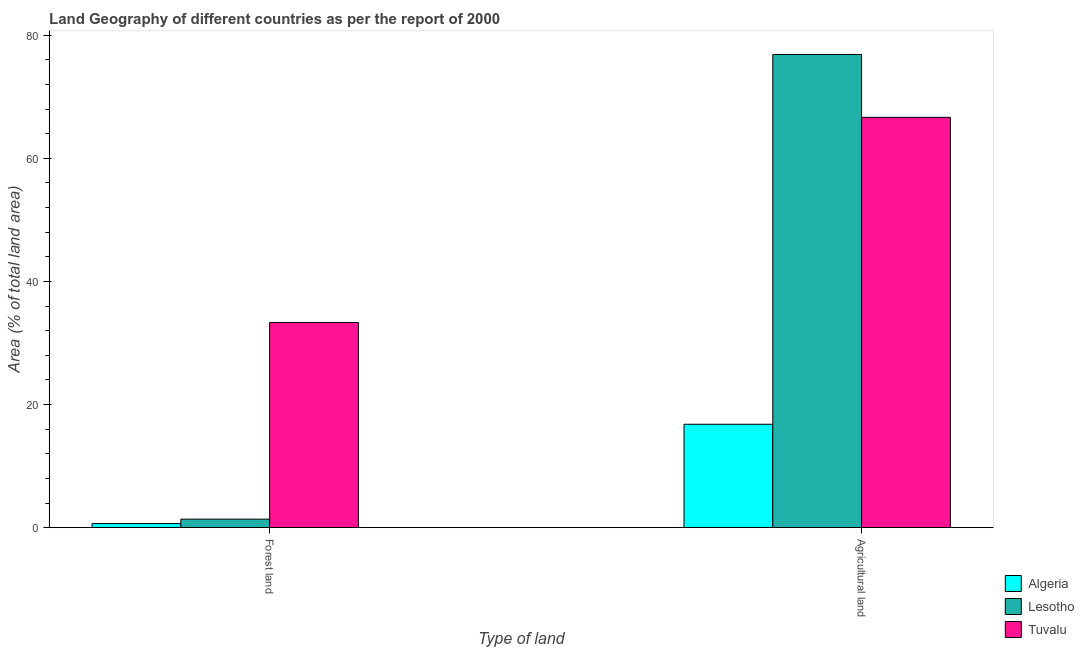How many groups of bars are there?
Make the answer very short. 2. Are the number of bars per tick equal to the number of legend labels?
Offer a terse response. Yes. How many bars are there on the 2nd tick from the right?
Give a very brief answer. 3. What is the label of the 1st group of bars from the left?
Give a very brief answer. Forest land. What is the percentage of land area under forests in Tuvalu?
Your response must be concise. 33.33. Across all countries, what is the maximum percentage of land area under forests?
Ensure brevity in your answer.  33.33. Across all countries, what is the minimum percentage of land area under forests?
Your answer should be compact. 0.66. In which country was the percentage of land area under forests maximum?
Give a very brief answer. Tuvalu. In which country was the percentage of land area under agriculture minimum?
Your response must be concise. Algeria. What is the total percentage of land area under agriculture in the graph?
Your answer should be compact. 160.35. What is the difference between the percentage of land area under agriculture in Tuvalu and that in Algeria?
Provide a succinct answer. 49.86. What is the difference between the percentage of land area under agriculture in Lesotho and the percentage of land area under forests in Algeria?
Give a very brief answer. 76.21. What is the average percentage of land area under forests per country?
Ensure brevity in your answer.  11.79. What is the difference between the percentage of land area under agriculture and percentage of land area under forests in Algeria?
Make the answer very short. 16.14. What is the ratio of the percentage of land area under forests in Tuvalu to that in Algeria?
Offer a very short reply. 50.28. What does the 2nd bar from the left in Agricultural land represents?
Your response must be concise. Lesotho. What does the 3rd bar from the right in Forest land represents?
Provide a short and direct response. Algeria. How many bars are there?
Provide a short and direct response. 6. Are all the bars in the graph horizontal?
Give a very brief answer. No. Does the graph contain grids?
Your answer should be compact. No. How many legend labels are there?
Make the answer very short. 3. What is the title of the graph?
Your answer should be very brief. Land Geography of different countries as per the report of 2000. Does "Zambia" appear as one of the legend labels in the graph?
Provide a short and direct response. No. What is the label or title of the X-axis?
Make the answer very short. Type of land. What is the label or title of the Y-axis?
Keep it short and to the point. Area (% of total land area). What is the Area (% of total land area) in Algeria in Forest land?
Your answer should be compact. 0.66. What is the Area (% of total land area) of Lesotho in Forest land?
Ensure brevity in your answer.  1.38. What is the Area (% of total land area) in Tuvalu in Forest land?
Offer a terse response. 33.33. What is the Area (% of total land area) of Algeria in Agricultural land?
Offer a terse response. 16.8. What is the Area (% of total land area) in Lesotho in Agricultural land?
Offer a very short reply. 76.88. What is the Area (% of total land area) of Tuvalu in Agricultural land?
Provide a short and direct response. 66.67. Across all Type of land, what is the maximum Area (% of total land area) of Algeria?
Ensure brevity in your answer.  16.8. Across all Type of land, what is the maximum Area (% of total land area) of Lesotho?
Your response must be concise. 76.88. Across all Type of land, what is the maximum Area (% of total land area) of Tuvalu?
Your answer should be compact. 66.67. Across all Type of land, what is the minimum Area (% of total land area) of Algeria?
Ensure brevity in your answer.  0.66. Across all Type of land, what is the minimum Area (% of total land area) in Lesotho?
Your response must be concise. 1.38. Across all Type of land, what is the minimum Area (% of total land area) in Tuvalu?
Provide a short and direct response. 33.33. What is the total Area (% of total land area) of Algeria in the graph?
Provide a short and direct response. 17.47. What is the total Area (% of total land area) of Lesotho in the graph?
Offer a very short reply. 78.26. What is the difference between the Area (% of total land area) in Algeria in Forest land and that in Agricultural land?
Provide a short and direct response. -16.14. What is the difference between the Area (% of total land area) of Lesotho in Forest land and that in Agricultural land?
Offer a terse response. -75.49. What is the difference between the Area (% of total land area) in Tuvalu in Forest land and that in Agricultural land?
Give a very brief answer. -33.33. What is the difference between the Area (% of total land area) in Algeria in Forest land and the Area (% of total land area) in Lesotho in Agricultural land?
Keep it short and to the point. -76.21. What is the difference between the Area (% of total land area) in Algeria in Forest land and the Area (% of total land area) in Tuvalu in Agricultural land?
Offer a very short reply. -66. What is the difference between the Area (% of total land area) of Lesotho in Forest land and the Area (% of total land area) of Tuvalu in Agricultural land?
Offer a terse response. -65.28. What is the average Area (% of total land area) in Algeria per Type of land?
Ensure brevity in your answer.  8.73. What is the average Area (% of total land area) in Lesotho per Type of land?
Give a very brief answer. 39.13. What is the difference between the Area (% of total land area) in Algeria and Area (% of total land area) in Lesotho in Forest land?
Keep it short and to the point. -0.72. What is the difference between the Area (% of total land area) in Algeria and Area (% of total land area) in Tuvalu in Forest land?
Your answer should be very brief. -32.67. What is the difference between the Area (% of total land area) of Lesotho and Area (% of total land area) of Tuvalu in Forest land?
Your answer should be compact. -31.95. What is the difference between the Area (% of total land area) in Algeria and Area (% of total land area) in Lesotho in Agricultural land?
Your answer should be compact. -60.07. What is the difference between the Area (% of total land area) in Algeria and Area (% of total land area) in Tuvalu in Agricultural land?
Your response must be concise. -49.86. What is the difference between the Area (% of total land area) in Lesotho and Area (% of total land area) in Tuvalu in Agricultural land?
Your response must be concise. 10.21. What is the ratio of the Area (% of total land area) in Algeria in Forest land to that in Agricultural land?
Offer a very short reply. 0.04. What is the ratio of the Area (% of total land area) in Lesotho in Forest land to that in Agricultural land?
Provide a succinct answer. 0.02. What is the ratio of the Area (% of total land area) of Tuvalu in Forest land to that in Agricultural land?
Make the answer very short. 0.5. What is the difference between the highest and the second highest Area (% of total land area) in Algeria?
Offer a very short reply. 16.14. What is the difference between the highest and the second highest Area (% of total land area) in Lesotho?
Give a very brief answer. 75.49. What is the difference between the highest and the second highest Area (% of total land area) of Tuvalu?
Provide a short and direct response. 33.33. What is the difference between the highest and the lowest Area (% of total land area) of Algeria?
Make the answer very short. 16.14. What is the difference between the highest and the lowest Area (% of total land area) of Lesotho?
Your answer should be compact. 75.49. What is the difference between the highest and the lowest Area (% of total land area) of Tuvalu?
Keep it short and to the point. 33.33. 